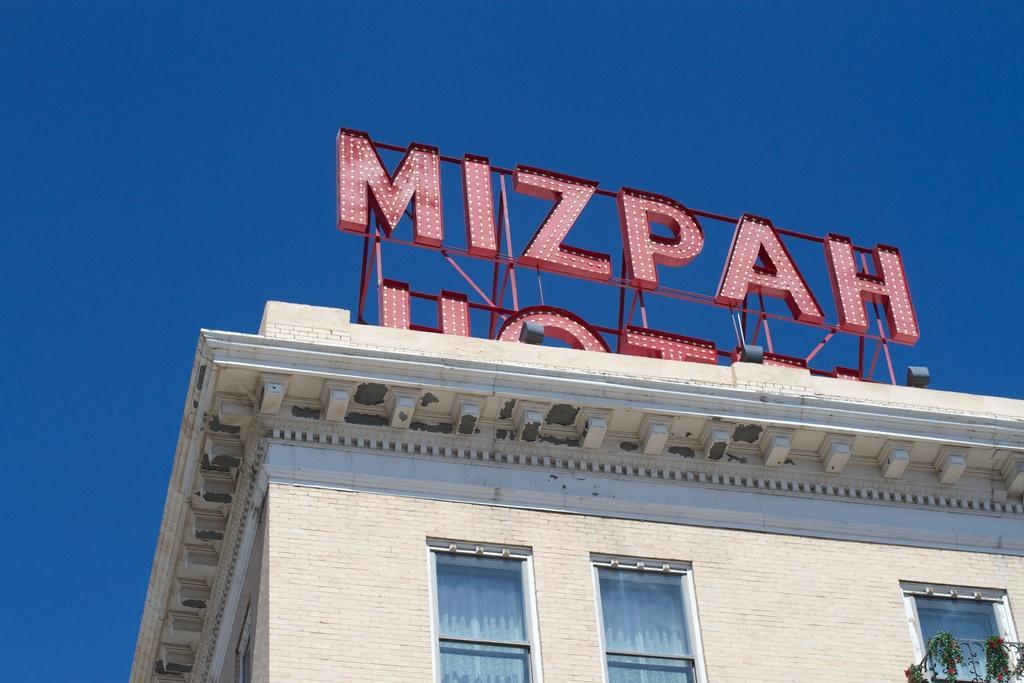In one or two sentences, can you explain what this image depicts? In this picture we can see a building, windows, wall, climbing plants and flowers. On a building we can see the naming boards. In the background of the image we can see the sky. 